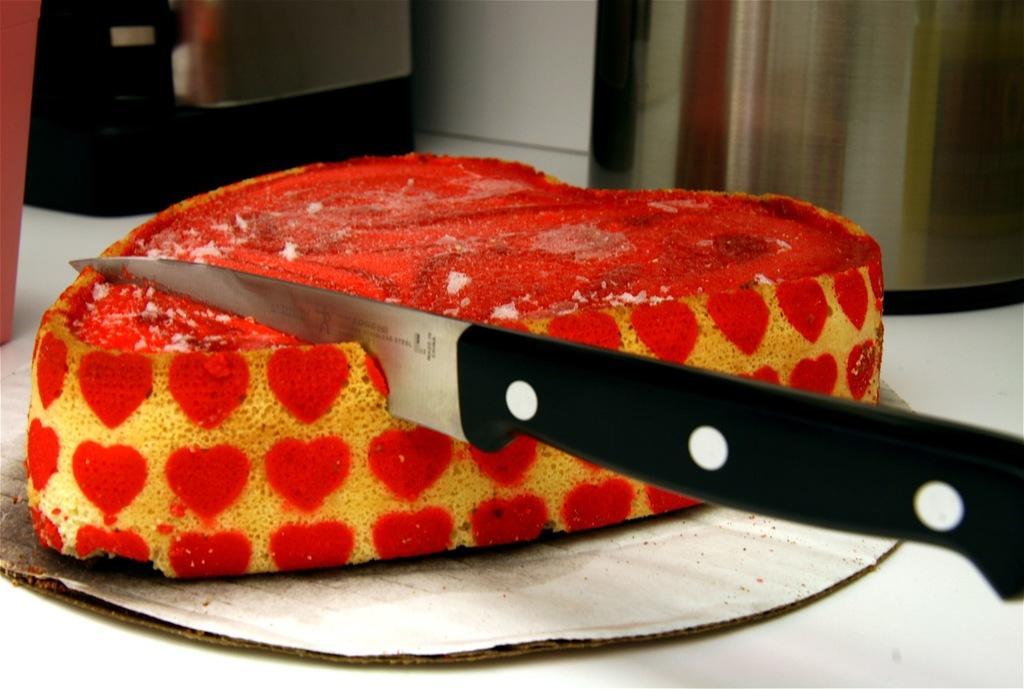In one or two sentences, can you explain what this image depicts? In the picture I can see a piece of cake and I can see the knife. 